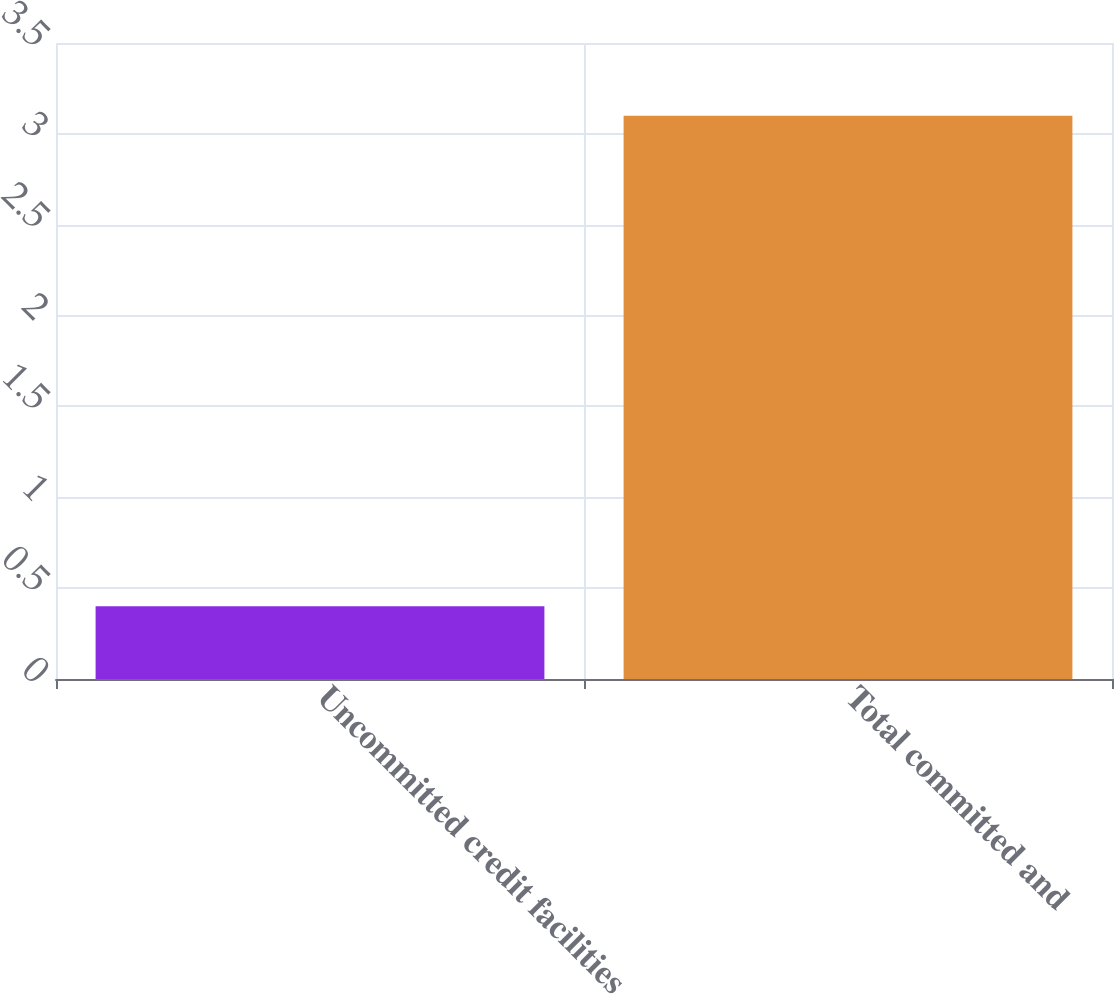Convert chart to OTSL. <chart><loc_0><loc_0><loc_500><loc_500><bar_chart><fcel>Uncommitted credit facilities<fcel>Total committed and<nl><fcel>0.4<fcel>3.1<nl></chart> 